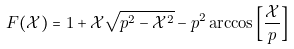<formula> <loc_0><loc_0><loc_500><loc_500>F ( \mathcal { X } ) = 1 + \mathcal { X } \sqrt { p ^ { 2 } - \mathcal { X } ^ { 2 } } - p ^ { 2 } \arccos \left [ \frac { \mathcal { X } } { p } \right ]</formula> 